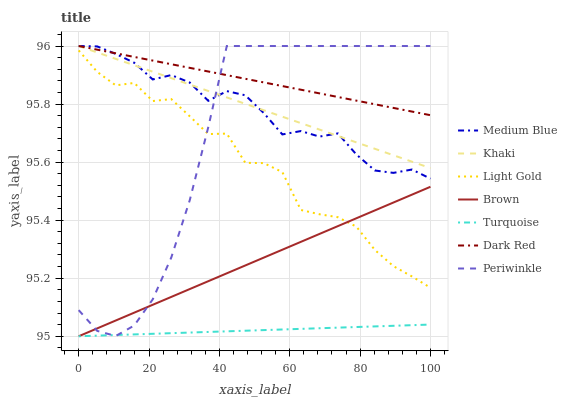Does Khaki have the minimum area under the curve?
Answer yes or no. No. Does Khaki have the maximum area under the curve?
Answer yes or no. No. Is Turquoise the smoothest?
Answer yes or no. No. Is Turquoise the roughest?
Answer yes or no. No. Does Khaki have the lowest value?
Answer yes or no. No. Does Turquoise have the highest value?
Answer yes or no. No. Is Turquoise less than Dark Red?
Answer yes or no. Yes. Is Khaki greater than Light Gold?
Answer yes or no. Yes. Does Turquoise intersect Dark Red?
Answer yes or no. No. 